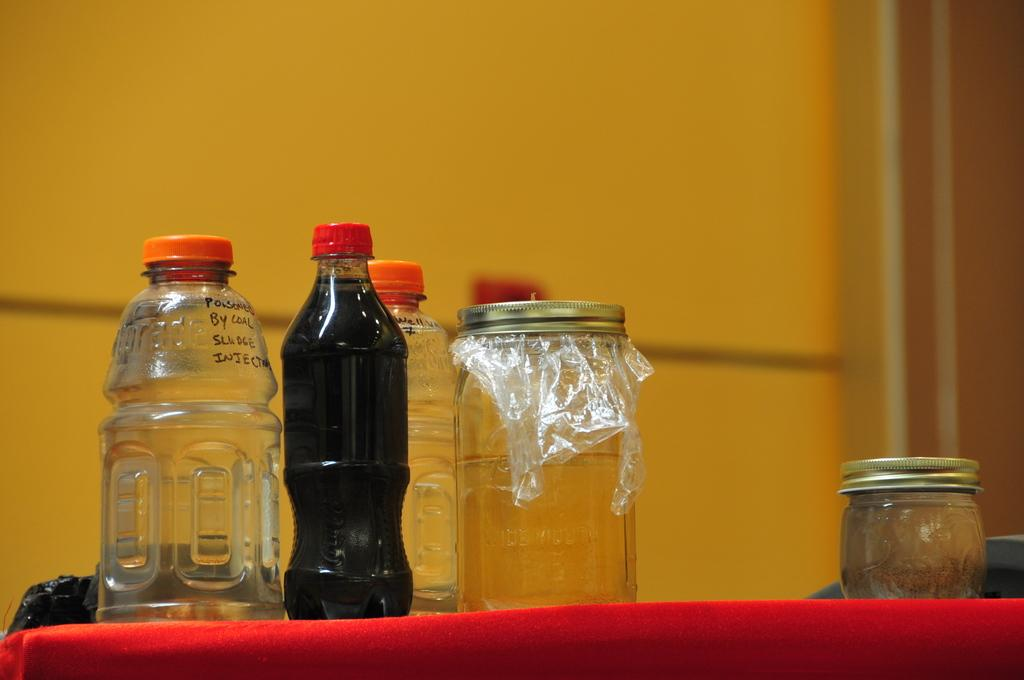<image>
Write a terse but informative summary of the picture. An empty Gatorade bottle has an orange cap. 